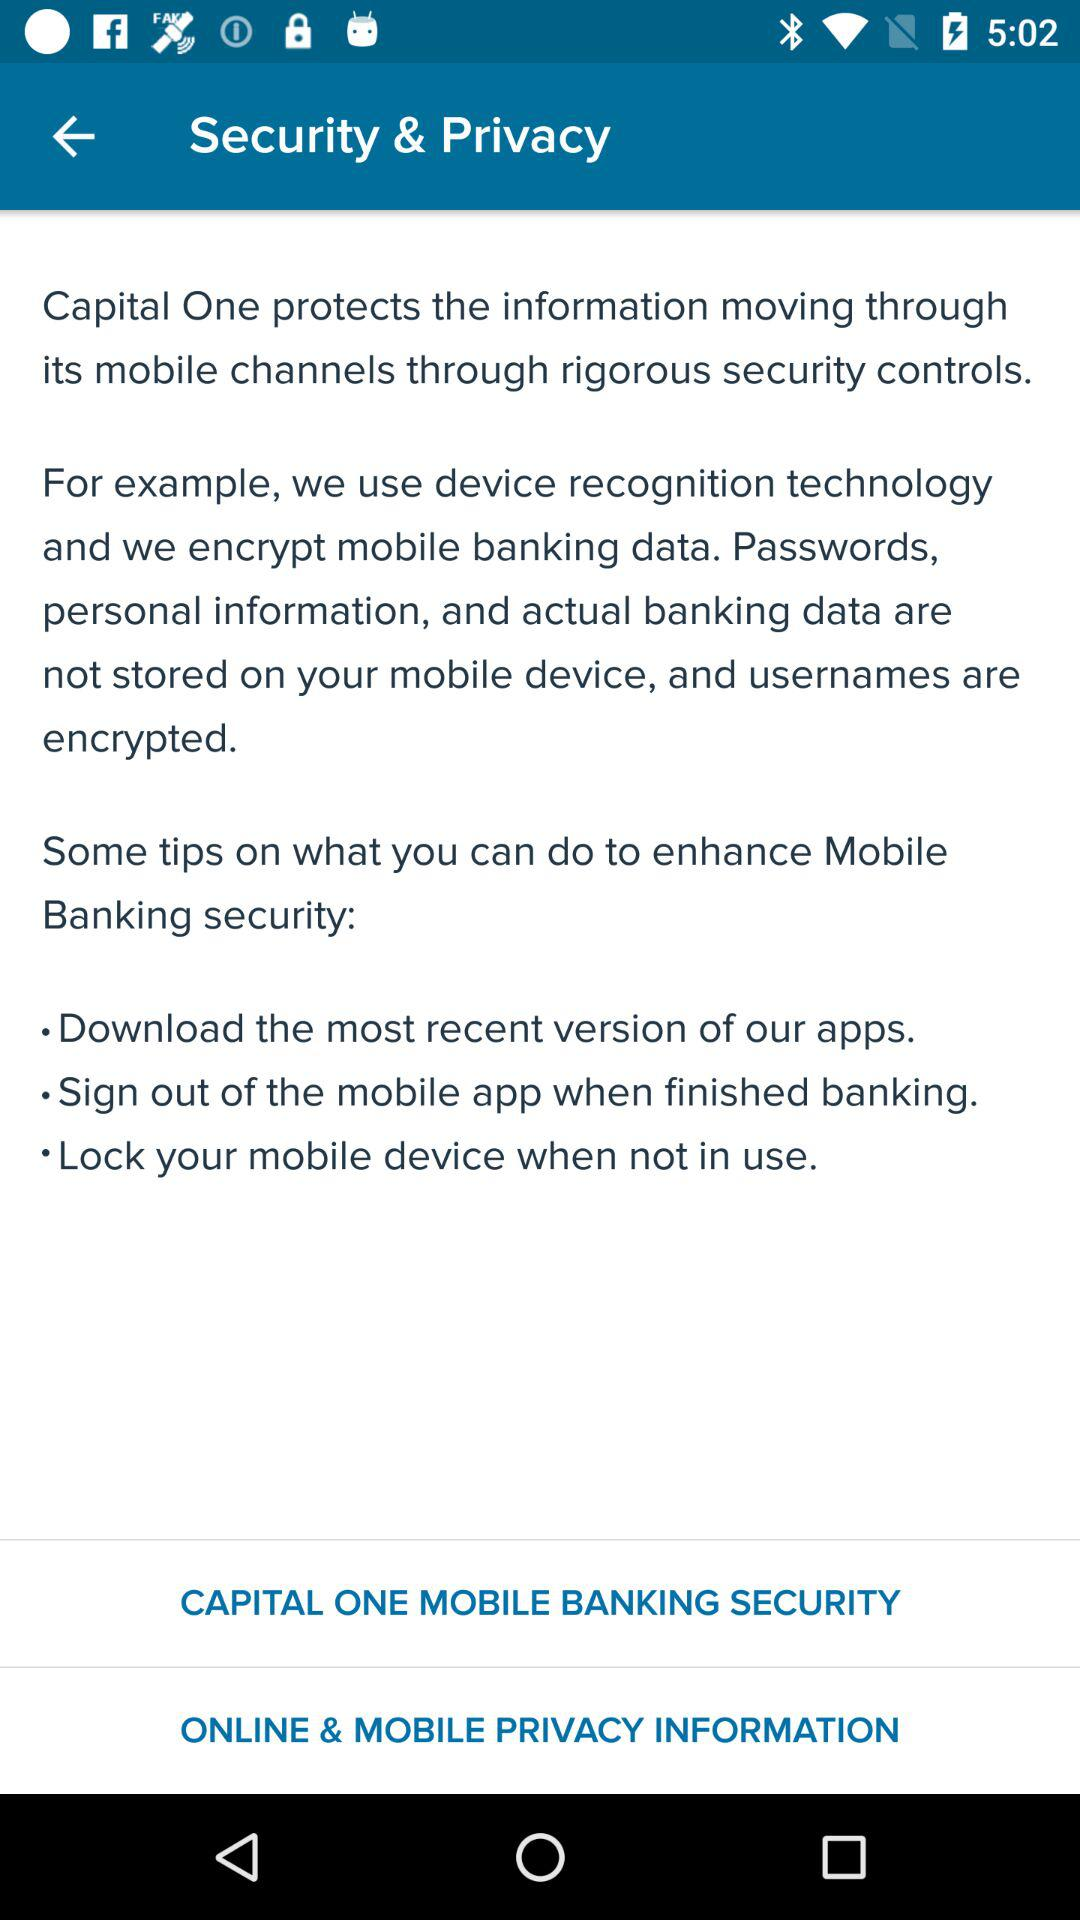How many security controls are mentioned?
Answer the question using a single word or phrase. 2 